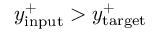<formula> <loc_0><loc_0><loc_500><loc_500>y _ { i n p u t } ^ { + } > y _ { t \arg e t } ^ { + }</formula> 